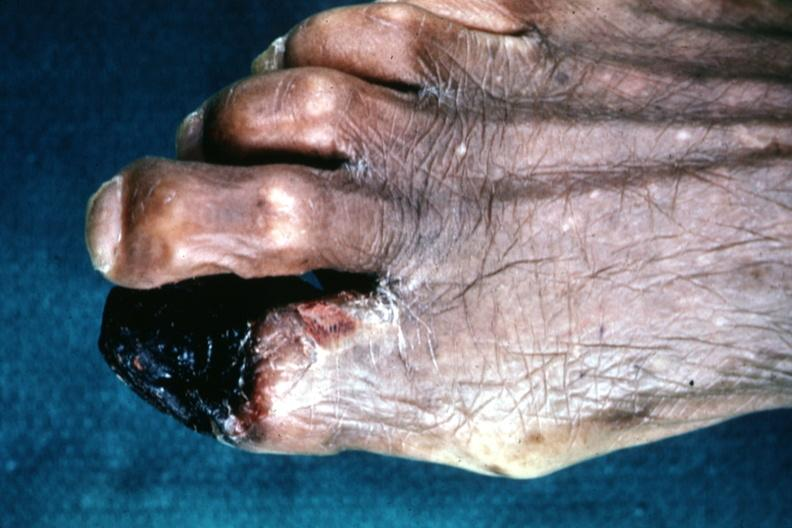s metastatic carcinoma prostate present?
Answer the question using a single word or phrase. No 